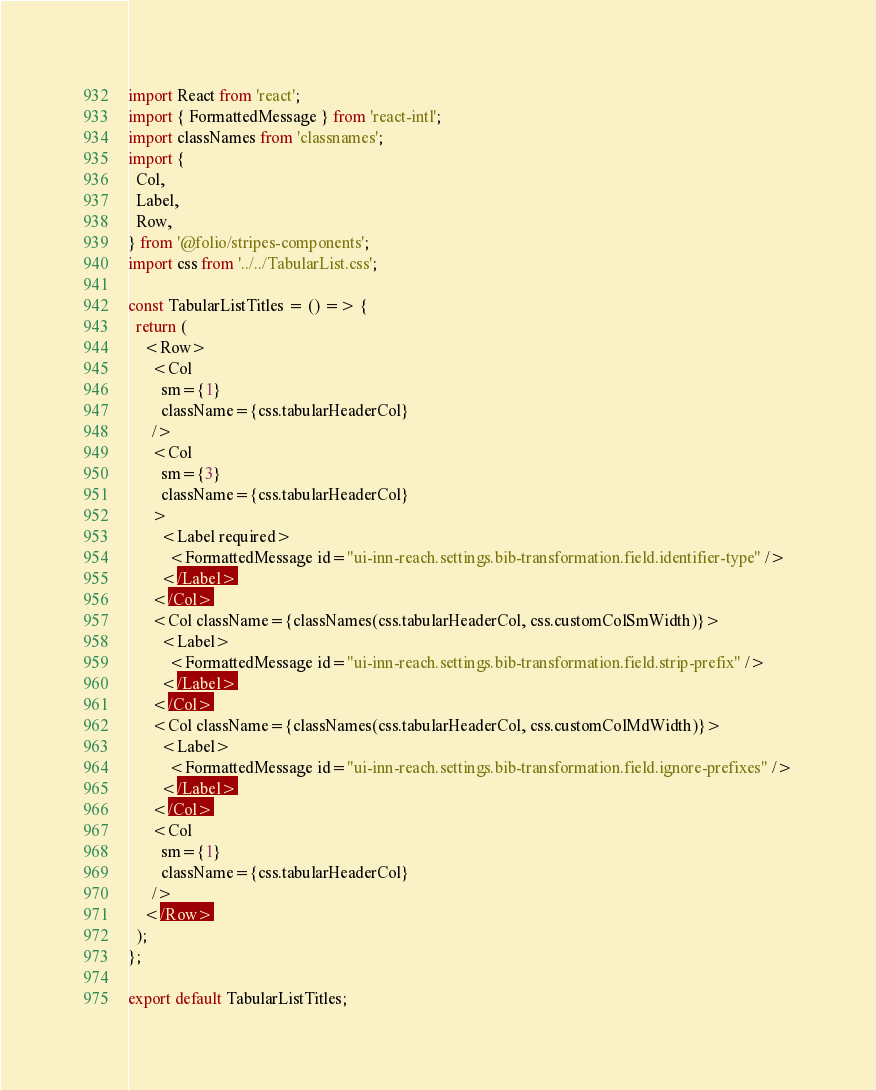<code> <loc_0><loc_0><loc_500><loc_500><_JavaScript_>import React from 'react';
import { FormattedMessage } from 'react-intl';
import classNames from 'classnames';
import {
  Col,
  Label,
  Row,
} from '@folio/stripes-components';
import css from '../../TabularList.css';

const TabularListTitles = () => {
  return (
    <Row>
      <Col
        sm={1}
        className={css.tabularHeaderCol}
      />
      <Col
        sm={3}
        className={css.tabularHeaderCol}
      >
        <Label required>
          <FormattedMessage id="ui-inn-reach.settings.bib-transformation.field.identifier-type" />
        </Label>
      </Col>
      <Col className={classNames(css.tabularHeaderCol, css.customColSmWidth)}>
        <Label>
          <FormattedMessage id="ui-inn-reach.settings.bib-transformation.field.strip-prefix" />
        </Label>
      </Col>
      <Col className={classNames(css.tabularHeaderCol, css.customColMdWidth)}>
        <Label>
          <FormattedMessage id="ui-inn-reach.settings.bib-transformation.field.ignore-prefixes" />
        </Label>
      </Col>
      <Col
        sm={1}
        className={css.tabularHeaderCol}
      />
    </Row>
  );
};

export default TabularListTitles;
</code> 